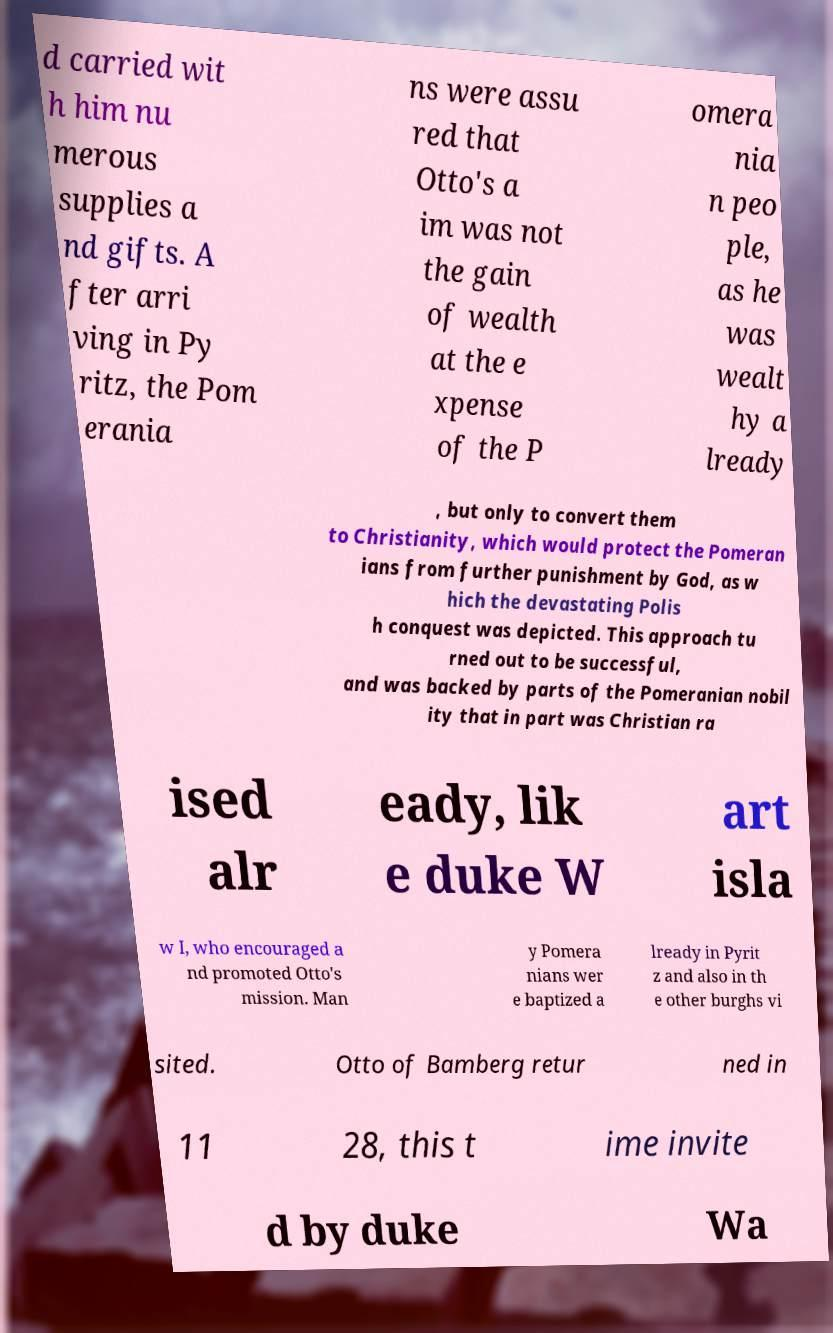What messages or text are displayed in this image? I need them in a readable, typed format. d carried wit h him nu merous supplies a nd gifts. A fter arri ving in Py ritz, the Pom erania ns were assu red that Otto's a im was not the gain of wealth at the e xpense of the P omera nia n peo ple, as he was wealt hy a lready , but only to convert them to Christianity, which would protect the Pomeran ians from further punishment by God, as w hich the devastating Polis h conquest was depicted. This approach tu rned out to be successful, and was backed by parts of the Pomeranian nobil ity that in part was Christian ra ised alr eady, lik e duke W art isla w I, who encouraged a nd promoted Otto's mission. Man y Pomera nians wer e baptized a lready in Pyrit z and also in th e other burghs vi sited. Otto of Bamberg retur ned in 11 28, this t ime invite d by duke Wa 